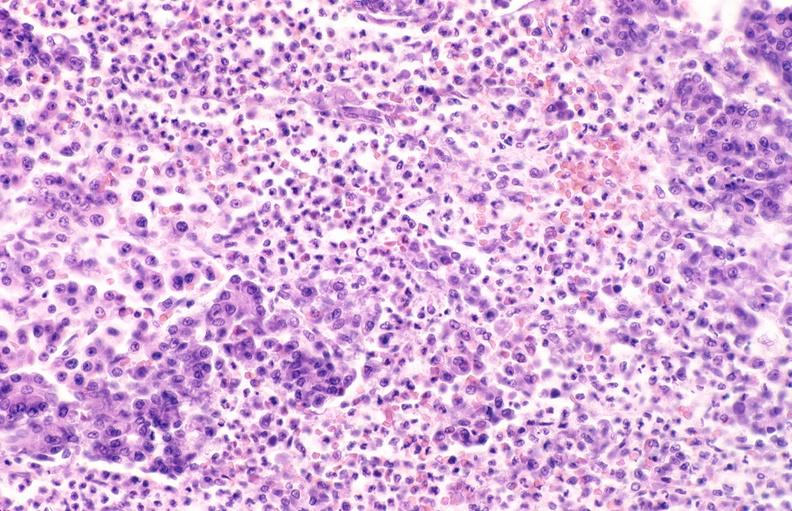what does this image show?
Answer the question using a single word or phrase. Pancreatic fat necrosis 